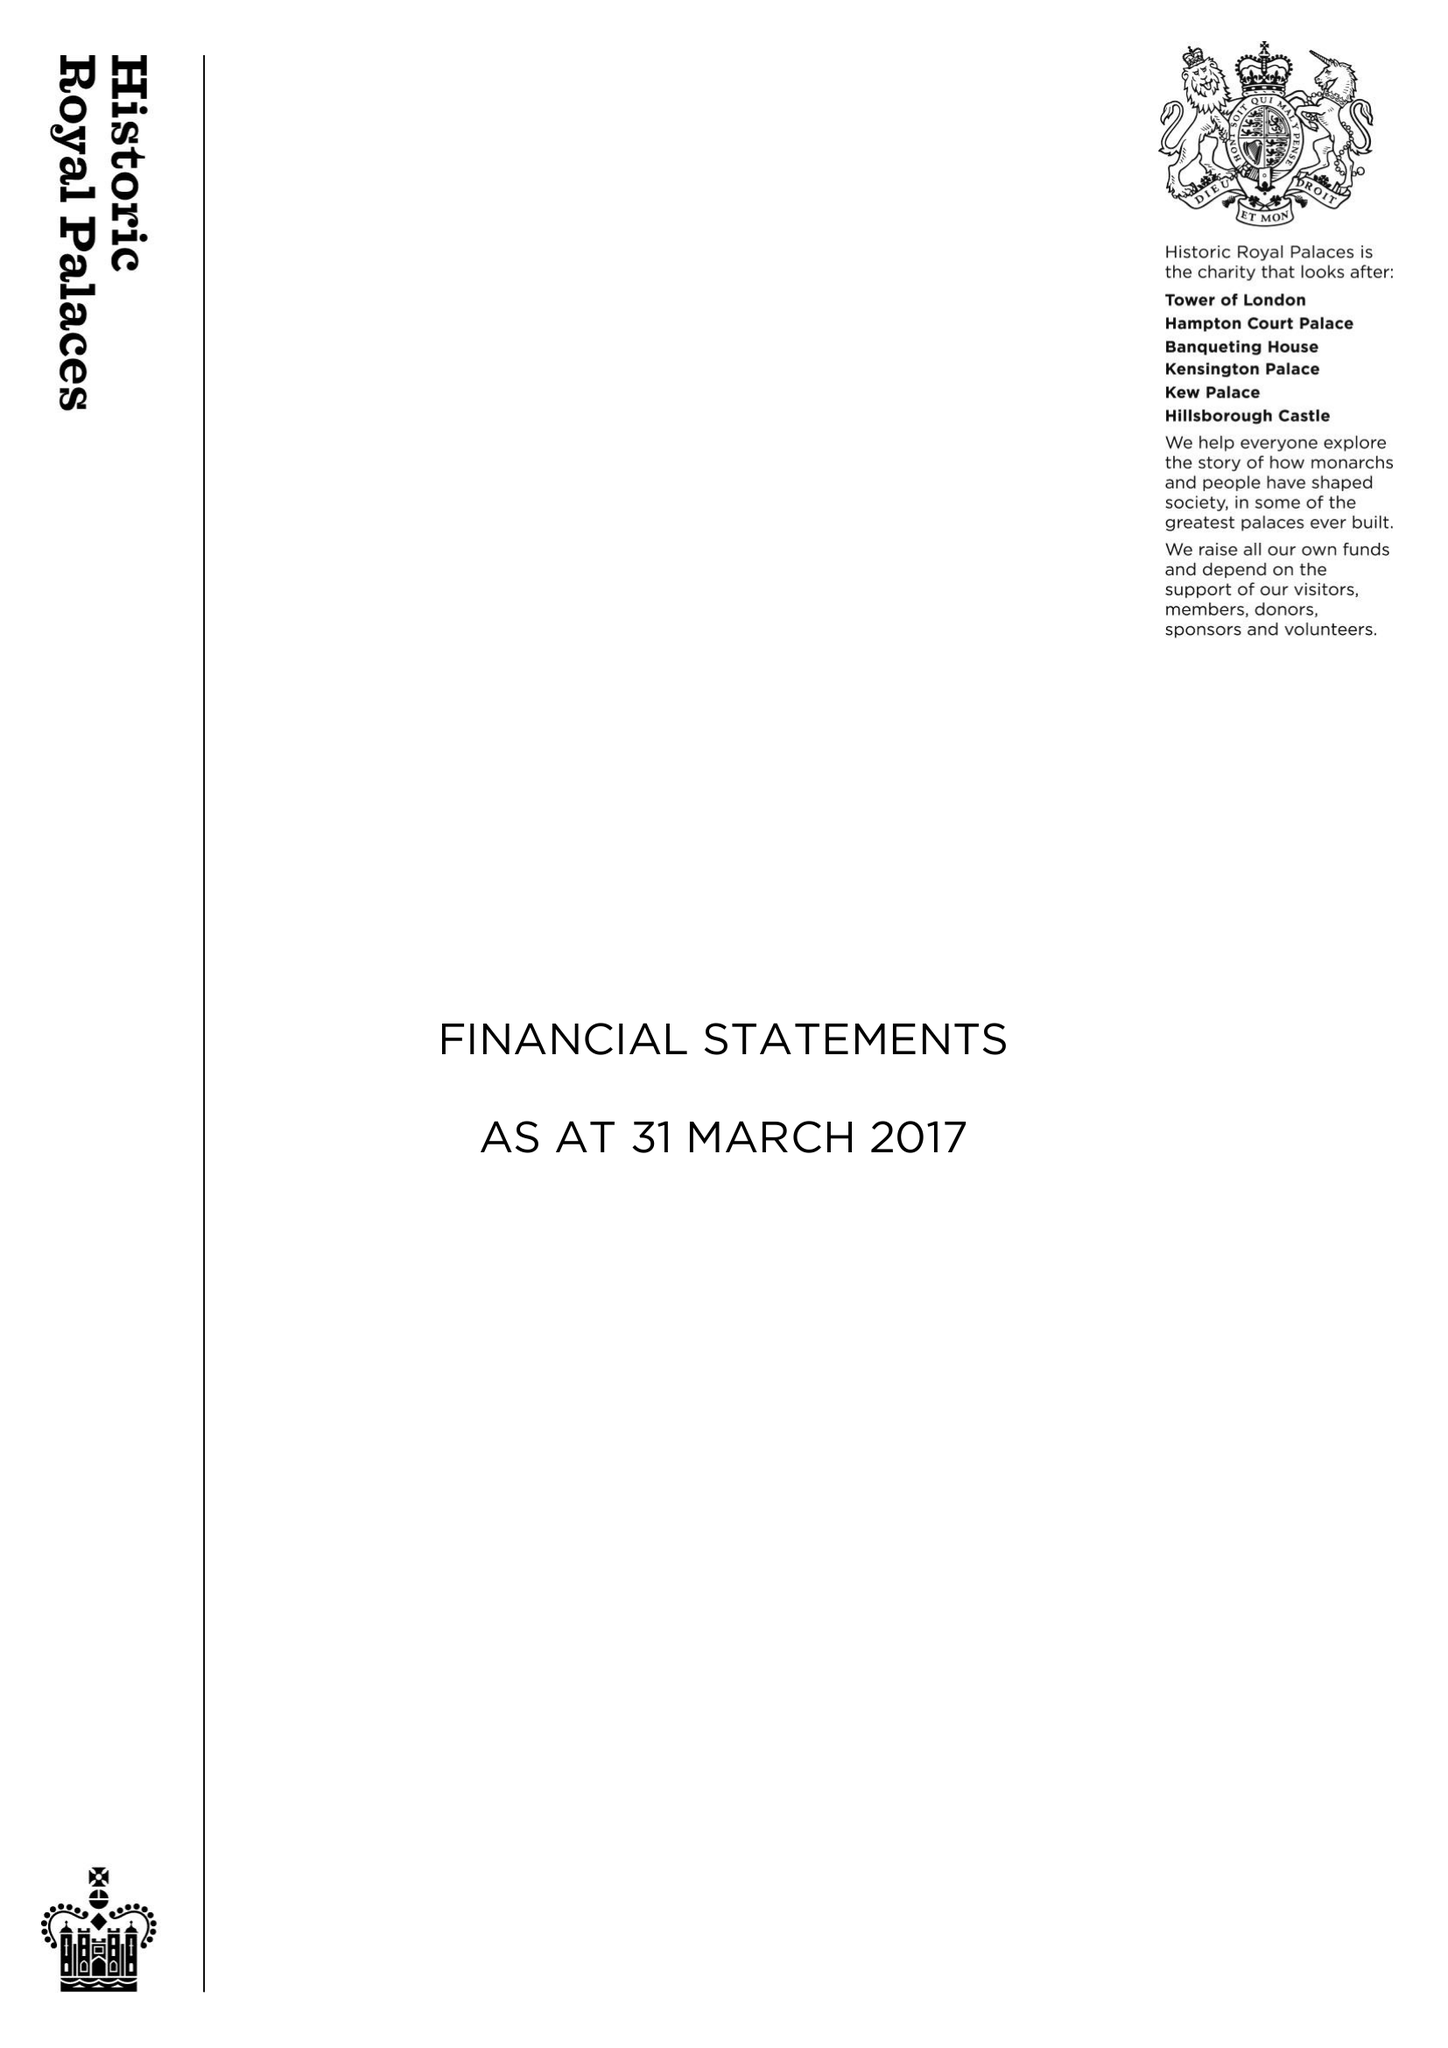What is the value for the address__post_town?
Answer the question using a single word or phrase. WEST MOLESEY 